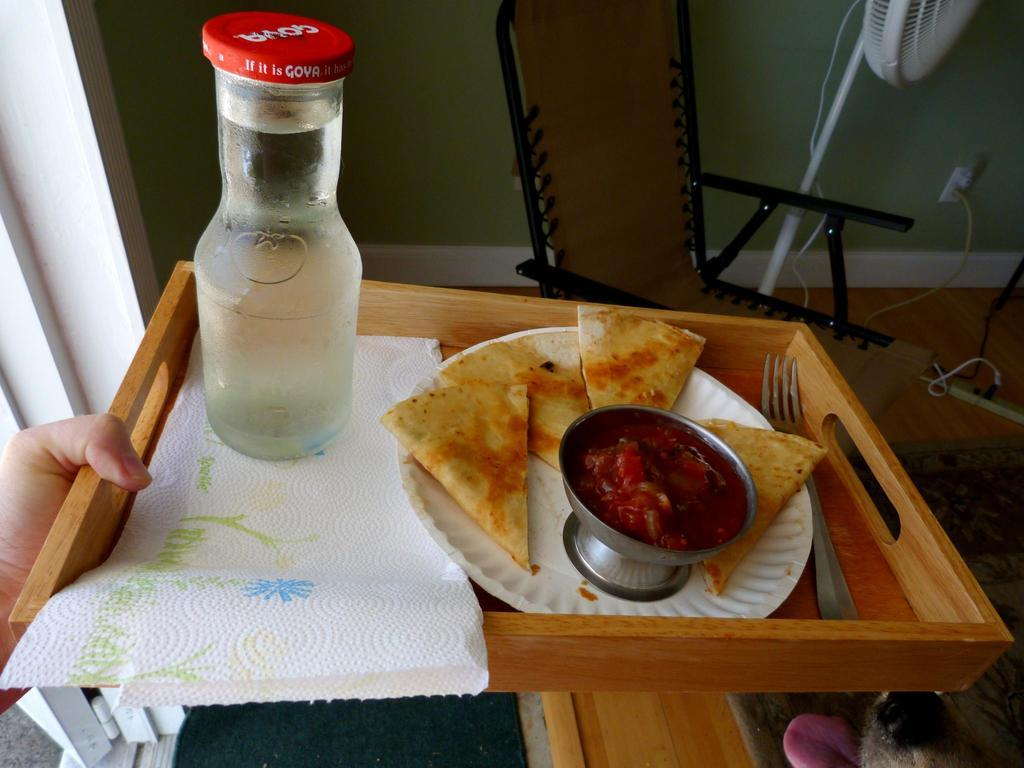<image>
Render a clear and concise summary of the photo. A breakfast tray with a bottle of liquid with the words 'if it is Gova' legible on the cap. 